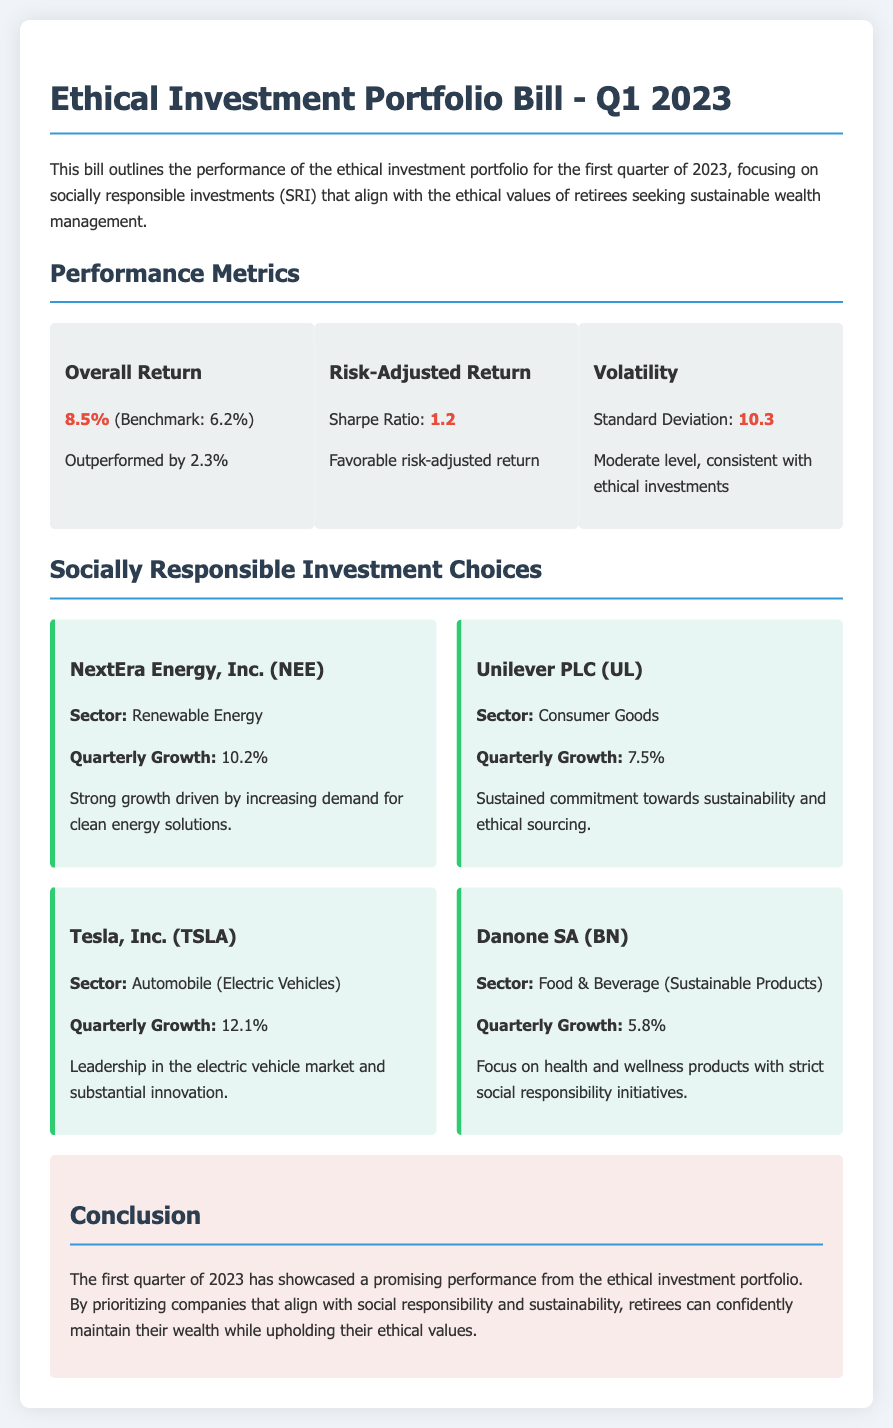What is the overall return for Q1 2023? The overall return is stated as 8.5%.
Answer: 8.5% What is the Sharpe Ratio mentioned in the bill? The Sharpe Ratio is provided as a measure of risk-adjusted return, which is 1.2.
Answer: 1.2 Which company had the highest quarterly growth? The document lists Tesla, Inc. with a quarterly growth of 12.1%.
Answer: Tesla, Inc What sector does Unilever PLC operate in? Unilever PLC is categorized under Consumer Goods.
Answer: Consumer Goods How much did Danone SA grow in the first quarter? Danone SA's quarterly growth is reported as 5.8%.
Answer: 5.8% What is the conclusion of the bill? The conclusion summarizes the positive performance of the portfolio and the alignment with ethical values.
Answer: Promising performance How does the overall return compare to the benchmark? The overall return outperformed the benchmark by 2.3%.
Answer: Outperformed by 2.3% What is the standard deviation mentioned for volatility? The standard deviation, which indicates the volatility level, is 10.3.
Answer: 10.3 Which company focuses on renewable energy? NextEra Energy, Inc. is identified as focusing on renewable energy.
Answer: NextEra Energy, Inc 